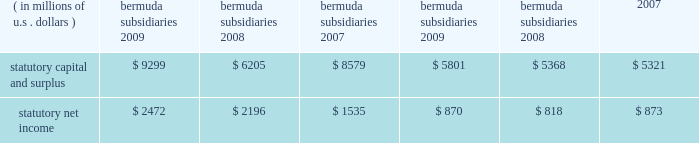N o t e s t o t h e c o n s o l i d a t e d f i n a n c i a l s t a t e m e n t s ( continued ) ace limited and subsidiaries 20 .
Statutory financial information the company 2019s insurance and reinsurance subsidiaries are subject to insurance laws and regulations in the jurisdictions in which they operate .
These regulations include restrictions that limit the amount of dividends or other distributions , such as loans or cash advances , available to shareholders without prior approval of the insurance regulatory authorities .
There are no statutory restrictions on the payment of dividends from retained earnings by any of the bermuda subsidiaries as the minimum statutory capital and surplus requirements are satisfied by the share capital and additional paid-in capital of each of the bermuda subsidiaries .
The company 2019s u.s .
Subsidiaries file financial statements prepared in accordance with statutory accounting practices prescribed or permitted by insurance regulators .
Statutory accounting differs from gaap in the reporting of certain reinsurance contracts , investments , subsidiaries , acquis- ition expenses , fixed assets , deferred income taxes , and certain other items .
The statutory capital and surplus of the u.s .
Subsidiaries met regulatory requirements for 2009 , 2008 , and 2007 .
The amount of dividends available to be paid in 2010 , without prior approval from the state insurance departments , totals $ 733 million .
The combined statutory capital and surplus and statutory net income of the bermuda and u.s .
Subsidiaries as at and for the years ended december 31 , 2009 , 2008 , and 2007 , are as follows: .
As permitted by the restructuring discussed previously in note 7 , certain of the company 2019s u.s .
Subsidiaries discount certain a&e liabilities , which increased statutory capital and surplus by approximately $ 215 million , $ 211 million , and $ 140 million at december 31 , 2009 , 2008 , and 2007 , respectively .
The company 2019s international subsidiaries prepare statutory financial statements based on local laws and regulations .
Some jurisdictions impose complex regulatory requirements on insurance companies while other jurisdictions impose fewer requirements .
In some countries , the company must obtain licenses issued by governmental authorities to conduct local insurance business .
These licenses may be subject to reserves and minimum capital and solvency tests .
Jurisdictions may impose fines , censure , and/or criminal sanctions for violation of regulatory requirements .
21 .
Information provided in connection with outstanding debt of subsidiaries the following tables present condensed consolidating financial information at december 31 , 2009 , and december 31 , 2008 , and for the years ended december 31 , 2009 , 2008 , and 2007 , for ace limited ( the parent guarantor ) and its 201csubsidiary issuer 201d , ace ina holdings , inc .
The subsidiary issuer is an indirect 100 percent-owned subsidiary of the parent guarantor .
Investments in subsidiaries are accounted for by the parent guarantor under the equity method for purposes of the supplemental consolidating presentation .
Earnings of subsidiaries are reflected in the parent guarantor 2019s investment accounts and earnings .
The parent guarantor fully and unconditionally guarantees certain of the debt of the subsidiary issuer. .
What was the percentage increase in the statutory capital and surplus due to discount of certain a&e liabilities from 2008 to 2009? 
Computations: ((215 - 211) / 211)
Answer: 0.01896. 